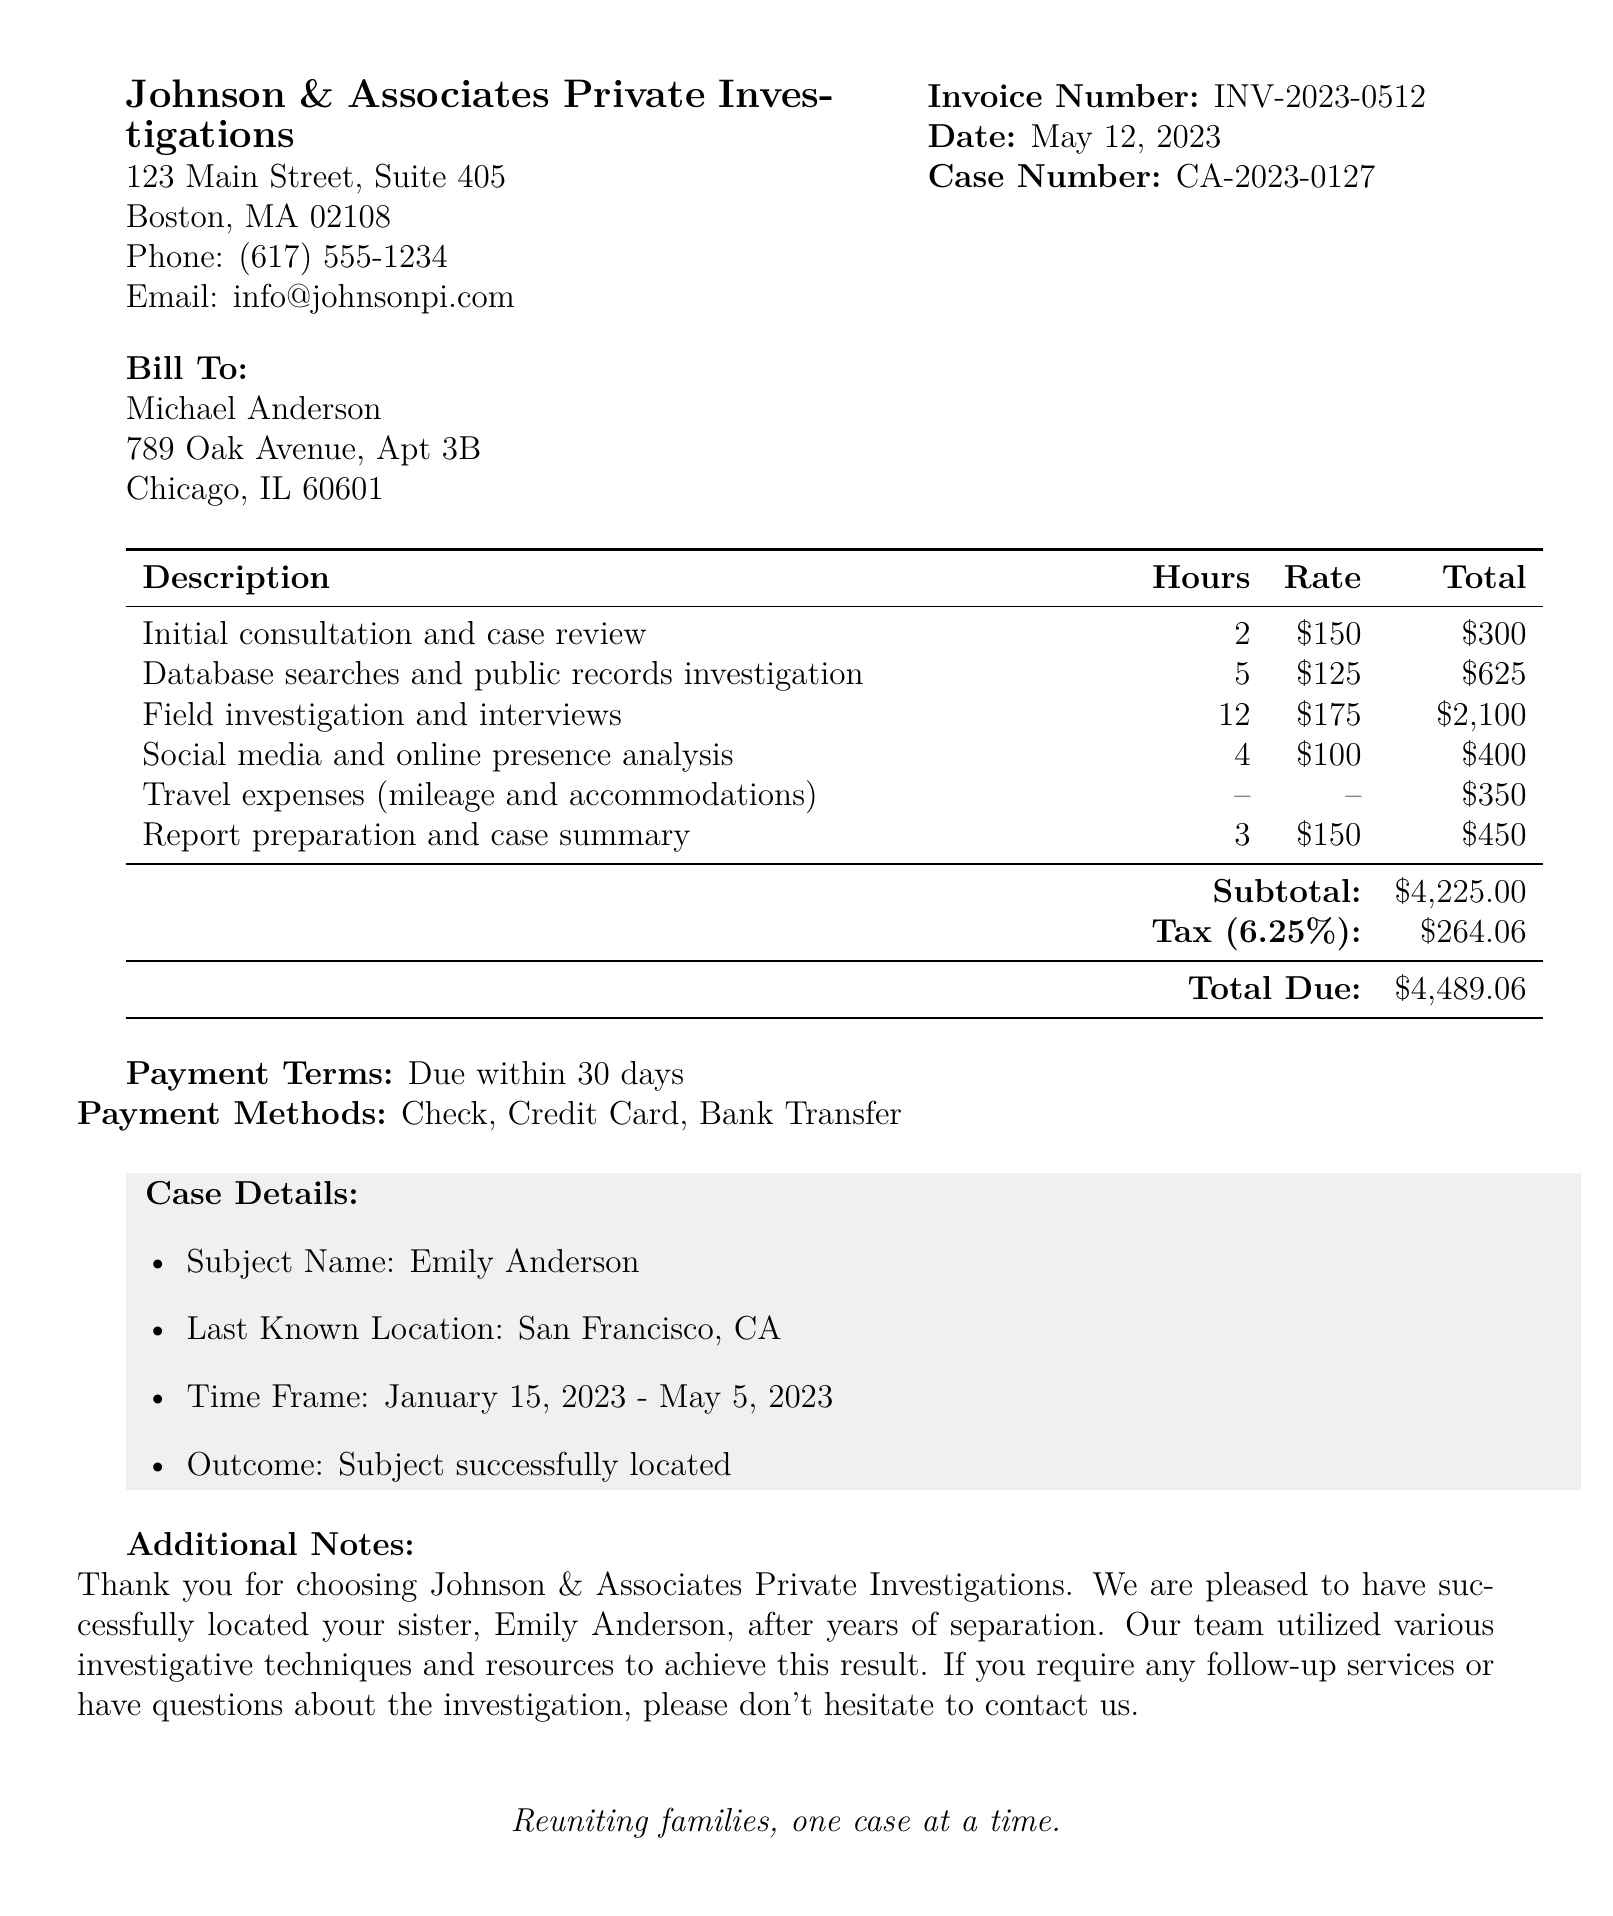What is the investigator's name? The document states that the investigator's name is Sarah Johnson.
Answer: Sarah Johnson What is the total amount due? The total amount due is the overall cost indicated at the end of the invoice, which is $4489.06.
Answer: $4489.06 How many hours were spent on field investigation and interviews? The document specifies that there were 12 hours spent on field investigation and interviews.
Answer: 12 What is the subject's last known location? The last known location of the subject, Emily Anderson, is listed as San Francisco, CA.
Answer: San Francisco, CA What is the rate for social media and online presence analysis? The rate for social media and online presence analysis is given as $100 per hour.
Answer: $100 What is the total for database searches and public records investigation? The total for database searches and public records investigation is $625 as specified in the services section.
Answer: $625 What is the case number? The case number is provided as CA-2023-0127 in the document.
Answer: CA-2023-0127 How many payment methods are listed? The document lists three payment methods available for settling the invoice.
Answer: Three What is the tax rate applied to the invoice? The tax rate indicated in the invoice is 6.25%.
Answer: 6.25% 